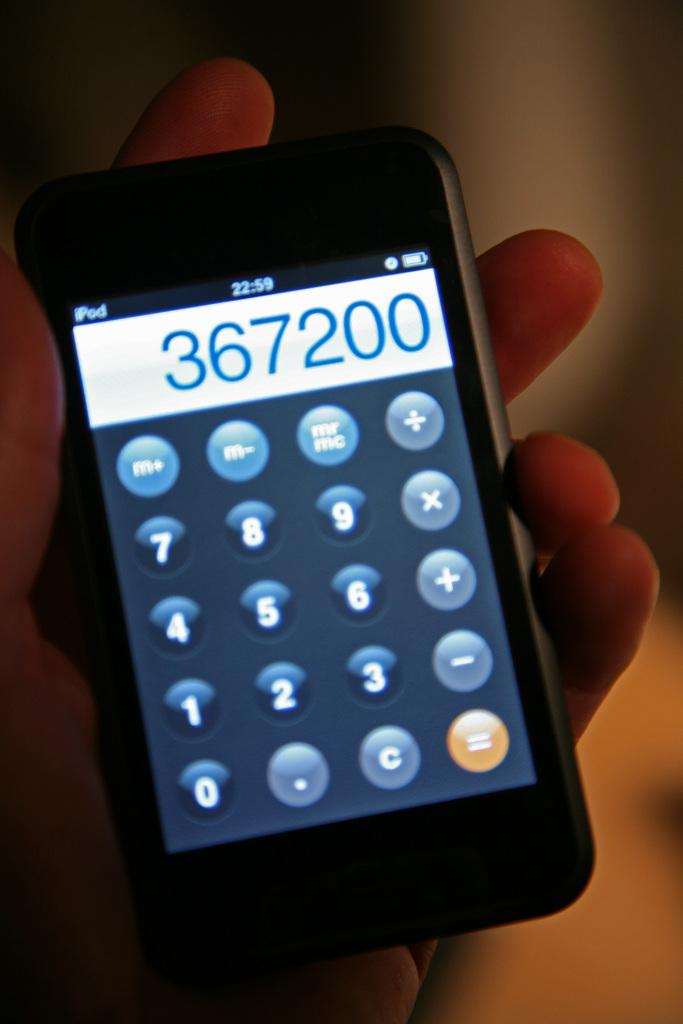<image>
Summarize the visual content of the image. An iPod logo can be seen on the top of a screen showing a calculator. 